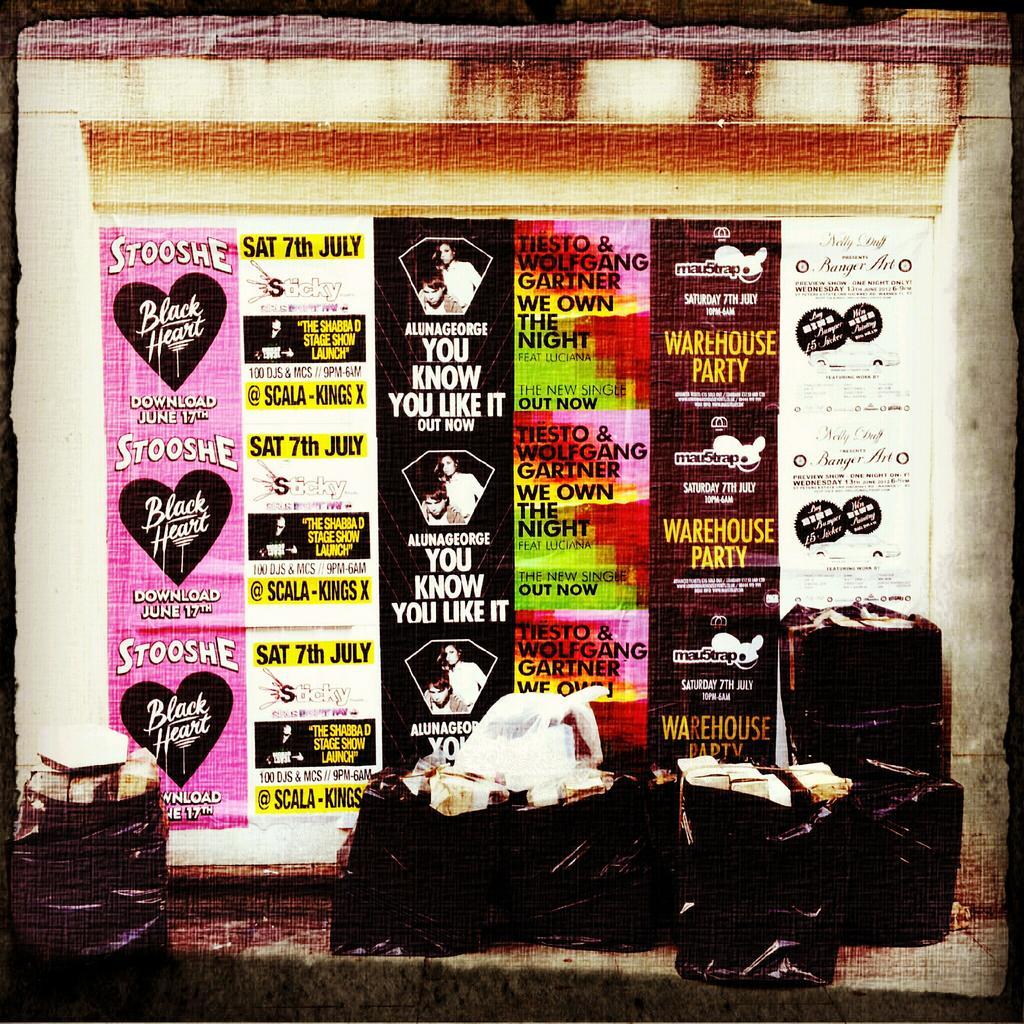Can you describe this image briefly? This image is an edited image. This image is taken outdoors. In the middle of the image there is a banner with a text on the wall. At the bottom of the image there is a sidewalk and there are a few things on the sidewalk. 